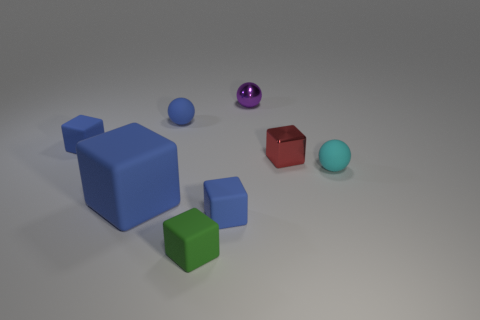Add 1 gray matte cylinders. How many objects exist? 9 Subtract all tiny purple metal balls. How many balls are left? 2 Subtract all red balls. How many blue blocks are left? 3 Subtract 2 cubes. How many cubes are left? 3 Subtract all blocks. How many objects are left? 3 Add 5 tiny brown rubber spheres. How many tiny brown rubber spheres exist? 5 Subtract all green blocks. How many blocks are left? 4 Subtract 0 yellow cubes. How many objects are left? 8 Subtract all gray balls. Subtract all red cylinders. How many balls are left? 3 Subtract all big yellow shiny objects. Subtract all small green objects. How many objects are left? 7 